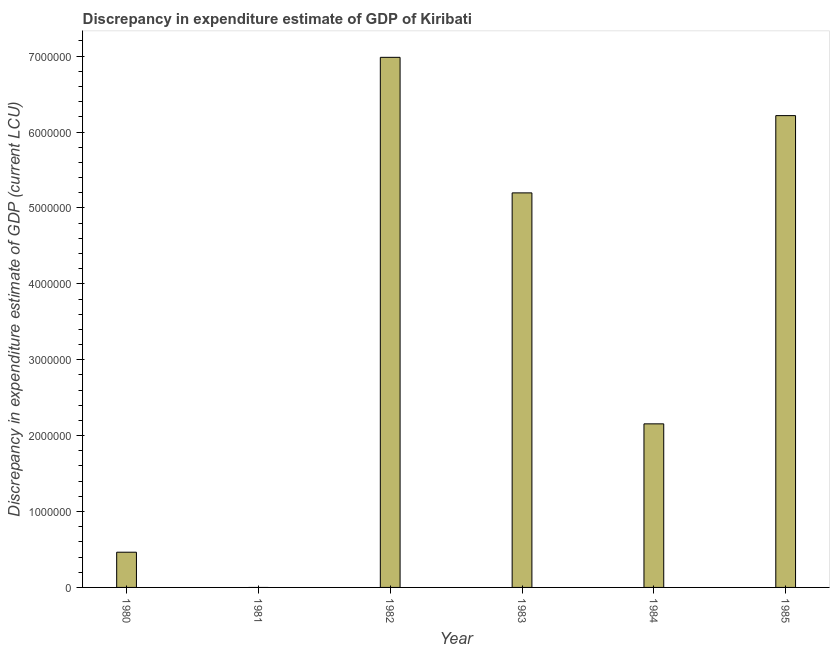Does the graph contain any zero values?
Your answer should be compact. Yes. Does the graph contain grids?
Offer a terse response. No. What is the title of the graph?
Offer a very short reply. Discrepancy in expenditure estimate of GDP of Kiribati. What is the label or title of the X-axis?
Your answer should be compact. Year. What is the label or title of the Y-axis?
Keep it short and to the point. Discrepancy in expenditure estimate of GDP (current LCU). What is the discrepancy in expenditure estimate of gdp in 1982?
Offer a very short reply. 6.98e+06. Across all years, what is the maximum discrepancy in expenditure estimate of gdp?
Offer a terse response. 6.98e+06. In which year was the discrepancy in expenditure estimate of gdp maximum?
Offer a terse response. 1982. What is the sum of the discrepancy in expenditure estimate of gdp?
Make the answer very short. 2.10e+07. What is the difference between the discrepancy in expenditure estimate of gdp in 1983 and 1985?
Your answer should be very brief. -1.02e+06. What is the average discrepancy in expenditure estimate of gdp per year?
Your answer should be compact. 3.50e+06. What is the median discrepancy in expenditure estimate of gdp?
Provide a succinct answer. 3.68e+06. In how many years, is the discrepancy in expenditure estimate of gdp greater than 3800000 LCU?
Give a very brief answer. 3. What is the ratio of the discrepancy in expenditure estimate of gdp in 1982 to that in 1984?
Offer a terse response. 3.24. Is the discrepancy in expenditure estimate of gdp in 1980 less than that in 1985?
Provide a short and direct response. Yes. Is the difference between the discrepancy in expenditure estimate of gdp in 1982 and 1985 greater than the difference between any two years?
Your answer should be compact. No. What is the difference between the highest and the second highest discrepancy in expenditure estimate of gdp?
Keep it short and to the point. 7.68e+05. Is the sum of the discrepancy in expenditure estimate of gdp in 1982 and 1983 greater than the maximum discrepancy in expenditure estimate of gdp across all years?
Ensure brevity in your answer.  Yes. What is the difference between the highest and the lowest discrepancy in expenditure estimate of gdp?
Your answer should be compact. 6.98e+06. In how many years, is the discrepancy in expenditure estimate of gdp greater than the average discrepancy in expenditure estimate of gdp taken over all years?
Your answer should be very brief. 3. Are all the bars in the graph horizontal?
Offer a very short reply. No. How many years are there in the graph?
Your answer should be very brief. 6. What is the difference between two consecutive major ticks on the Y-axis?
Ensure brevity in your answer.  1.00e+06. Are the values on the major ticks of Y-axis written in scientific E-notation?
Your response must be concise. No. What is the Discrepancy in expenditure estimate of GDP (current LCU) of 1980?
Provide a succinct answer. 4.64e+05. What is the Discrepancy in expenditure estimate of GDP (current LCU) in 1982?
Your answer should be very brief. 6.98e+06. What is the Discrepancy in expenditure estimate of GDP (current LCU) in 1983?
Your response must be concise. 5.20e+06. What is the Discrepancy in expenditure estimate of GDP (current LCU) in 1984?
Keep it short and to the point. 2.16e+06. What is the Discrepancy in expenditure estimate of GDP (current LCU) in 1985?
Ensure brevity in your answer.  6.22e+06. What is the difference between the Discrepancy in expenditure estimate of GDP (current LCU) in 1980 and 1982?
Make the answer very short. -6.52e+06. What is the difference between the Discrepancy in expenditure estimate of GDP (current LCU) in 1980 and 1983?
Keep it short and to the point. -4.73e+06. What is the difference between the Discrepancy in expenditure estimate of GDP (current LCU) in 1980 and 1984?
Your answer should be very brief. -1.69e+06. What is the difference between the Discrepancy in expenditure estimate of GDP (current LCU) in 1980 and 1985?
Offer a terse response. -5.75e+06. What is the difference between the Discrepancy in expenditure estimate of GDP (current LCU) in 1982 and 1983?
Your answer should be very brief. 1.79e+06. What is the difference between the Discrepancy in expenditure estimate of GDP (current LCU) in 1982 and 1984?
Your answer should be compact. 4.83e+06. What is the difference between the Discrepancy in expenditure estimate of GDP (current LCU) in 1982 and 1985?
Offer a very short reply. 7.68e+05. What is the difference between the Discrepancy in expenditure estimate of GDP (current LCU) in 1983 and 1984?
Keep it short and to the point. 3.04e+06. What is the difference between the Discrepancy in expenditure estimate of GDP (current LCU) in 1983 and 1985?
Ensure brevity in your answer.  -1.02e+06. What is the difference between the Discrepancy in expenditure estimate of GDP (current LCU) in 1984 and 1985?
Provide a succinct answer. -4.06e+06. What is the ratio of the Discrepancy in expenditure estimate of GDP (current LCU) in 1980 to that in 1982?
Your answer should be very brief. 0.07. What is the ratio of the Discrepancy in expenditure estimate of GDP (current LCU) in 1980 to that in 1983?
Make the answer very short. 0.09. What is the ratio of the Discrepancy in expenditure estimate of GDP (current LCU) in 1980 to that in 1984?
Your answer should be very brief. 0.21. What is the ratio of the Discrepancy in expenditure estimate of GDP (current LCU) in 1980 to that in 1985?
Make the answer very short. 0.07. What is the ratio of the Discrepancy in expenditure estimate of GDP (current LCU) in 1982 to that in 1983?
Offer a terse response. 1.34. What is the ratio of the Discrepancy in expenditure estimate of GDP (current LCU) in 1982 to that in 1984?
Ensure brevity in your answer.  3.24. What is the ratio of the Discrepancy in expenditure estimate of GDP (current LCU) in 1982 to that in 1985?
Give a very brief answer. 1.12. What is the ratio of the Discrepancy in expenditure estimate of GDP (current LCU) in 1983 to that in 1984?
Offer a terse response. 2.41. What is the ratio of the Discrepancy in expenditure estimate of GDP (current LCU) in 1983 to that in 1985?
Your answer should be compact. 0.84. What is the ratio of the Discrepancy in expenditure estimate of GDP (current LCU) in 1984 to that in 1985?
Ensure brevity in your answer.  0.35. 